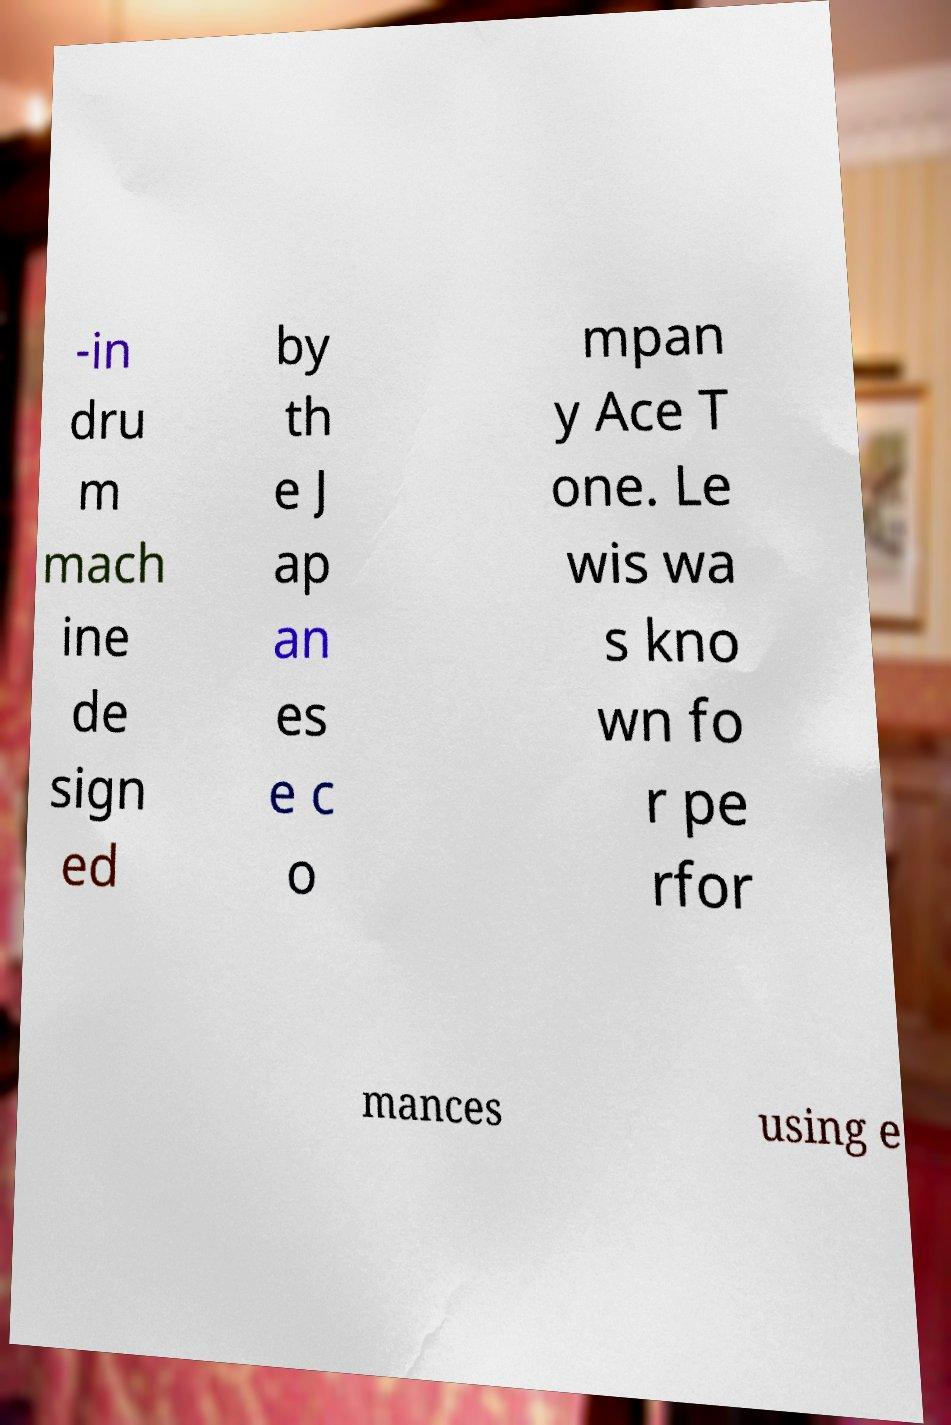Could you assist in decoding the text presented in this image and type it out clearly? -in dru m mach ine de sign ed by th e J ap an es e c o mpan y Ace T one. Le wis wa s kno wn fo r pe rfor mances using e 